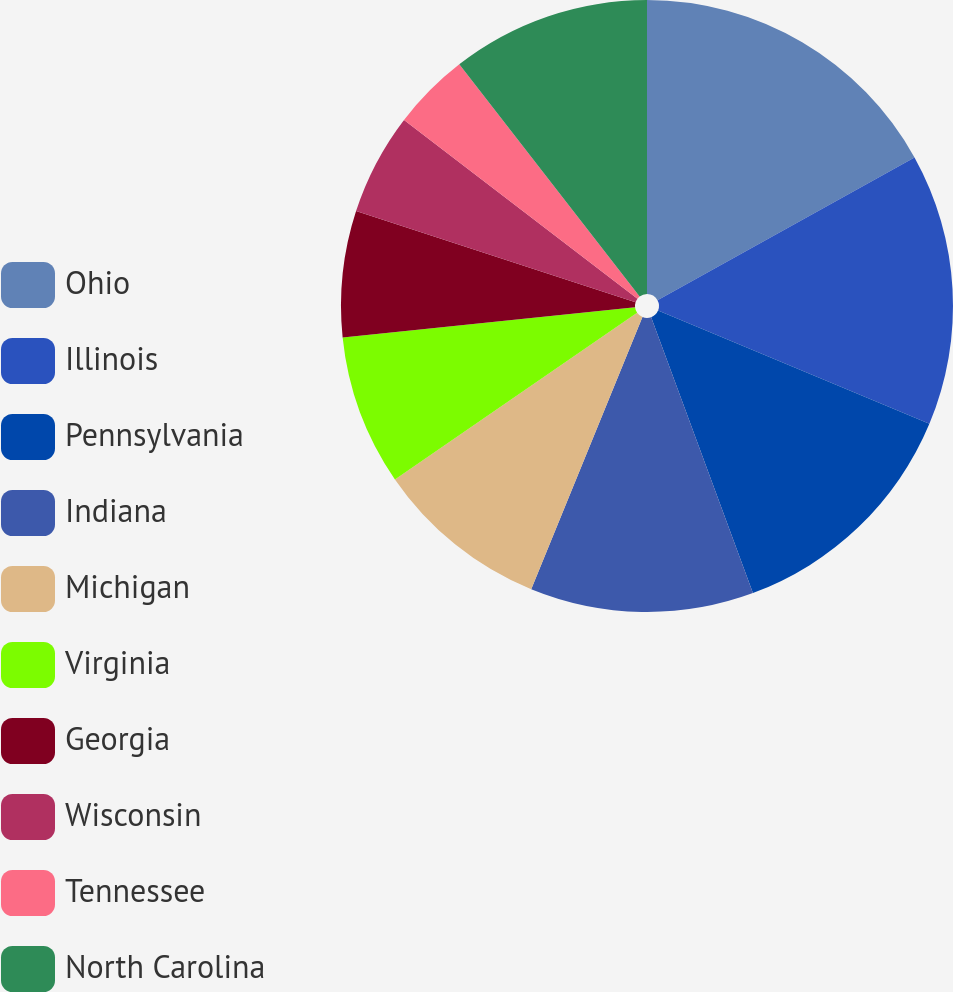Convert chart to OTSL. <chart><loc_0><loc_0><loc_500><loc_500><pie_chart><fcel>Ohio<fcel>Illinois<fcel>Pennsylvania<fcel>Indiana<fcel>Michigan<fcel>Virginia<fcel>Georgia<fcel>Wisconsin<fcel>Tennessee<fcel>North Carolina<nl><fcel>16.93%<fcel>14.36%<fcel>13.08%<fcel>11.8%<fcel>9.23%<fcel>7.95%<fcel>6.66%<fcel>5.38%<fcel>4.09%<fcel>10.51%<nl></chart> 